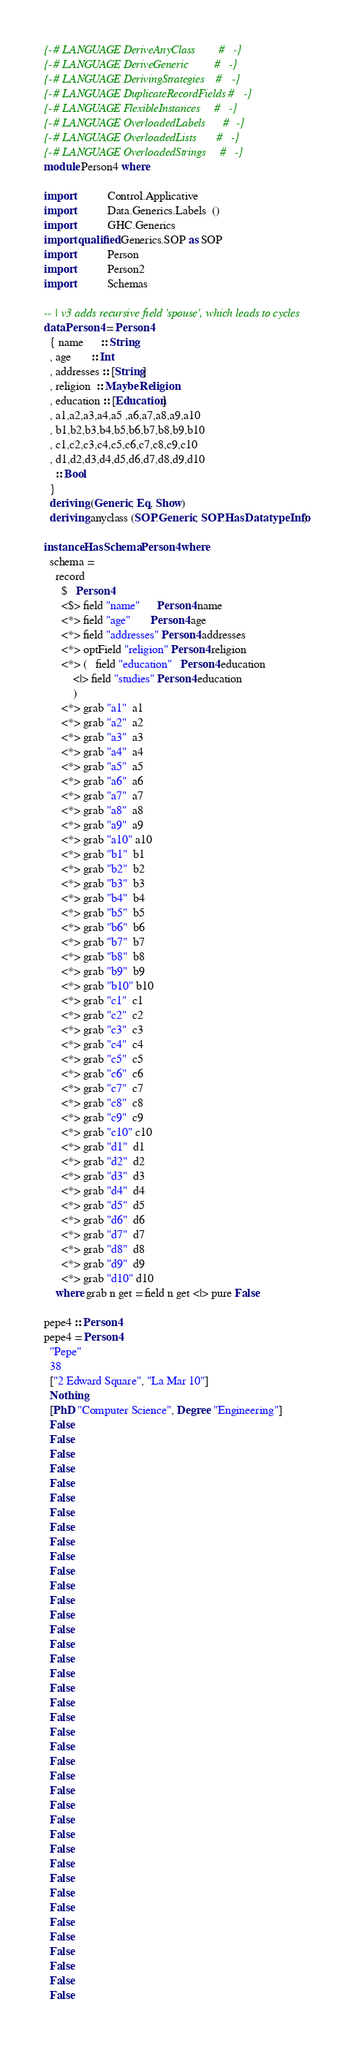Convert code to text. <code><loc_0><loc_0><loc_500><loc_500><_Haskell_>{-# LANGUAGE DeriveAnyClass        #-}
{-# LANGUAGE DeriveGeneric         #-}
{-# LANGUAGE DerivingStrategies    #-}
{-# LANGUAGE DuplicateRecordFields #-}
{-# LANGUAGE FlexibleInstances     #-}
{-# LANGUAGE OverloadedLabels      #-}
{-# LANGUAGE OverloadedLists       #-}
{-# LANGUAGE OverloadedStrings     #-}
module Person4 where

import           Control.Applicative
import           Data.Generics.Labels  ()
import           GHC.Generics
import qualified Generics.SOP as SOP
import           Person
import           Person2
import           Schemas

-- | v3 adds recursive field 'spouse', which leads to cycles
data Person4 = Person4
  { name      :: String
  , age       :: Int
  , addresses :: [String]
  , religion  :: Maybe Religion
  , education :: [Education]
  , a1,a2,a3,a4,a5 ,a6,a7,a8,a9,a10
  , b1,b2,b3,b4,b5,b6,b7,b8,b9,b10
  , c1,c2,c3,c4,c5,c6,c7,c8,c9,c10
  , d1,d2,d3,d4,d5,d6,d7,d8,d9,d10
    :: Bool
  }
  deriving (Generic, Eq, Show)
  deriving anyclass (SOP.Generic, SOP.HasDatatypeInfo)

instance HasSchema Person4 where
  schema =
    record
      $   Person4
      <$> field "name"      Person4.name
      <*> field "age"       Person4.age
      <*> field "addresses" Person4.addresses
      <*> optField "religion" Person4.religion
      <*> (   field "education"   Person4.education
          <|> field "studies" Person4.education
          )
      <*> grab "a1"  a1
      <*> grab "a2"  a2
      <*> grab "a3"  a3
      <*> grab "a4"  a4
      <*> grab "a5"  a5
      <*> grab "a6"  a6
      <*> grab "a7"  a7
      <*> grab "a8"  a8
      <*> grab "a9"  a9
      <*> grab "a10" a10
      <*> grab "b1"  b1
      <*> grab "b2"  b2
      <*> grab "b3"  b3
      <*> grab "b4"  b4
      <*> grab "b5"  b5
      <*> grab "b6"  b6
      <*> grab "b7"  b7
      <*> grab "b8"  b8
      <*> grab "b9"  b9
      <*> grab "b10" b10
      <*> grab "c1"  c1
      <*> grab "c2"  c2
      <*> grab "c3"  c3
      <*> grab "c4"  c4
      <*> grab "c5"  c5
      <*> grab "c6"  c6
      <*> grab "c7"  c7
      <*> grab "c8"  c8
      <*> grab "c9"  c9
      <*> grab "c10" c10
      <*> grab "d1"  d1
      <*> grab "d2"  d2
      <*> grab "d3"  d3
      <*> grab "d4"  d4
      <*> grab "d5"  d5
      <*> grab "d6"  d6
      <*> grab "d7"  d7
      <*> grab "d8"  d8
      <*> grab "d9"  d9
      <*> grab "d10" d10
    where grab n get = field n get <|> pure False

pepe4 :: Person4
pepe4 = Person4
  "Pepe"
  38
  ["2 Edward Square", "La Mar 10"]
  Nothing
  [PhD "Computer Science", Degree "Engineering"]
  False
  False
  False
  False
  False
  False
  False
  False
  False
  False
  False
  False
  False
  False
  False
  False
  False
  False
  False
  False
  False
  False
  False
  False
  False
  False
  False
  False
  False
  False
  False
  False
  False
  False
  False
  False
  False
  False
  False
  False
</code> 